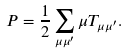Convert formula to latex. <formula><loc_0><loc_0><loc_500><loc_500>P = \frac { 1 } { 2 } \sum _ { \mu \mu ^ { \prime } } \mu T _ { \mu \mu ^ { \prime } } .</formula> 